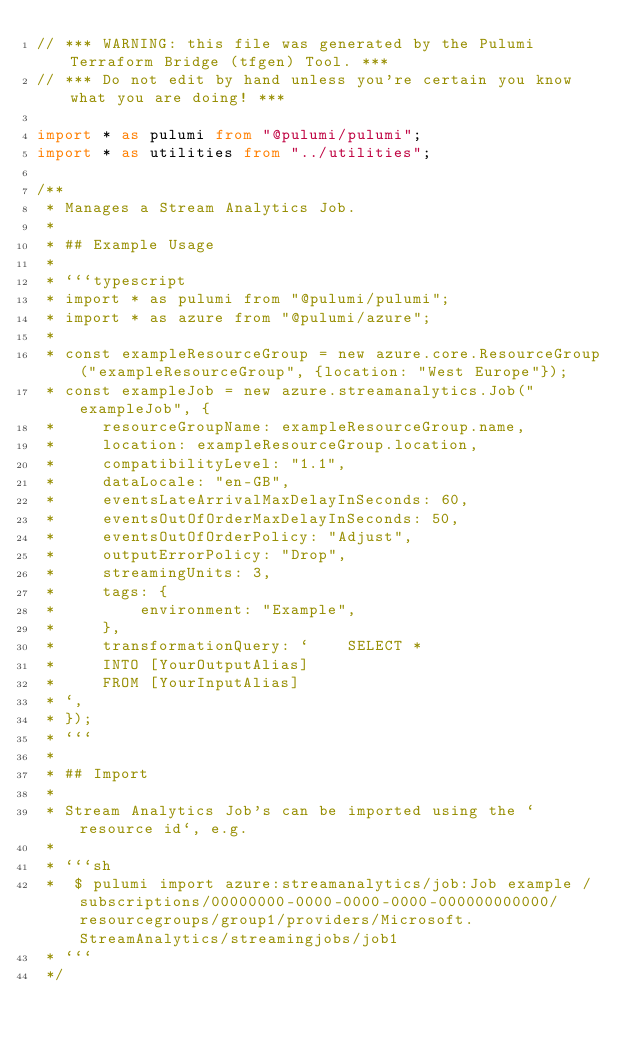<code> <loc_0><loc_0><loc_500><loc_500><_TypeScript_>// *** WARNING: this file was generated by the Pulumi Terraform Bridge (tfgen) Tool. ***
// *** Do not edit by hand unless you're certain you know what you are doing! ***

import * as pulumi from "@pulumi/pulumi";
import * as utilities from "../utilities";

/**
 * Manages a Stream Analytics Job.
 *
 * ## Example Usage
 *
 * ```typescript
 * import * as pulumi from "@pulumi/pulumi";
 * import * as azure from "@pulumi/azure";
 *
 * const exampleResourceGroup = new azure.core.ResourceGroup("exampleResourceGroup", {location: "West Europe"});
 * const exampleJob = new azure.streamanalytics.Job("exampleJob", {
 *     resourceGroupName: exampleResourceGroup.name,
 *     location: exampleResourceGroup.location,
 *     compatibilityLevel: "1.1",
 *     dataLocale: "en-GB",
 *     eventsLateArrivalMaxDelayInSeconds: 60,
 *     eventsOutOfOrderMaxDelayInSeconds: 50,
 *     eventsOutOfOrderPolicy: "Adjust",
 *     outputErrorPolicy: "Drop",
 *     streamingUnits: 3,
 *     tags: {
 *         environment: "Example",
 *     },
 *     transformationQuery: `    SELECT *
 *     INTO [YourOutputAlias]
 *     FROM [YourInputAlias]
 * `,
 * });
 * ```
 *
 * ## Import
 *
 * Stream Analytics Job's can be imported using the `resource id`, e.g.
 *
 * ```sh
 *  $ pulumi import azure:streamanalytics/job:Job example /subscriptions/00000000-0000-0000-0000-000000000000/resourcegroups/group1/providers/Microsoft.StreamAnalytics/streamingjobs/job1
 * ```
 */</code> 